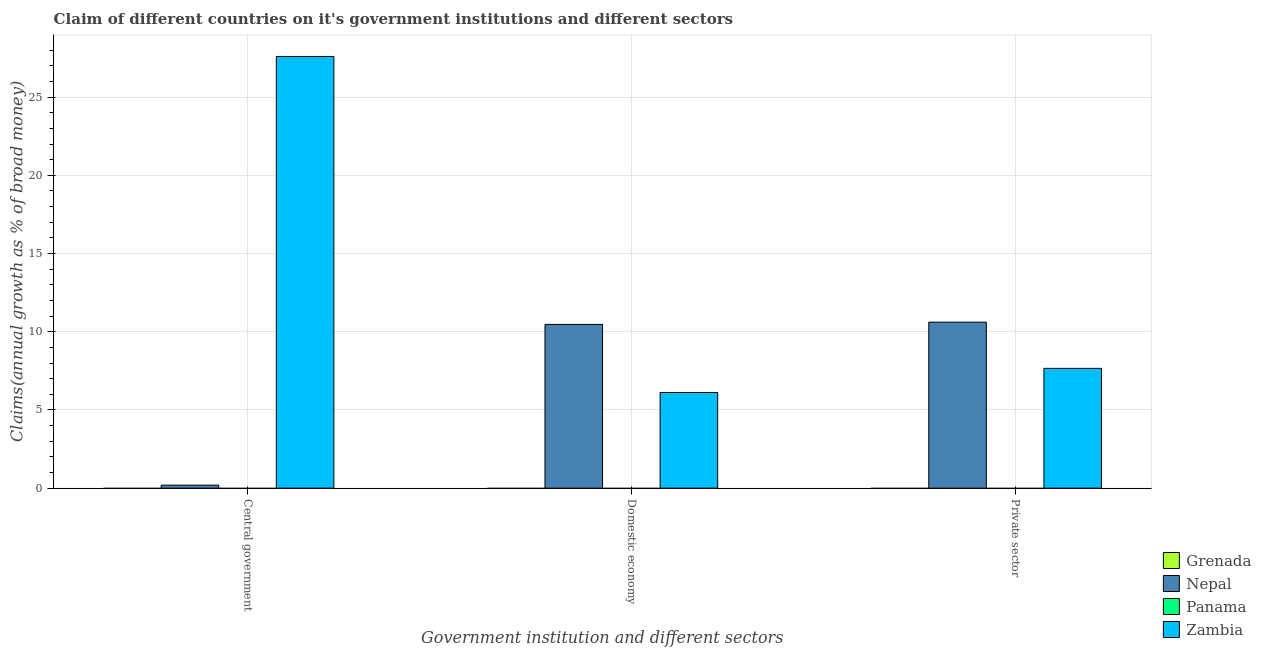How many different coloured bars are there?
Your response must be concise. 2. How many bars are there on the 3rd tick from the left?
Give a very brief answer. 2. How many bars are there on the 2nd tick from the right?
Give a very brief answer. 2. What is the label of the 2nd group of bars from the left?
Provide a succinct answer. Domestic economy. What is the percentage of claim on the domestic economy in Grenada?
Keep it short and to the point. 0. Across all countries, what is the maximum percentage of claim on the private sector?
Ensure brevity in your answer.  10.61. Across all countries, what is the minimum percentage of claim on the domestic economy?
Provide a short and direct response. 0. In which country was the percentage of claim on the central government maximum?
Offer a very short reply. Zambia. What is the total percentage of claim on the domestic economy in the graph?
Give a very brief answer. 16.59. What is the difference between the percentage of claim on the domestic economy in Zambia and that in Nepal?
Your response must be concise. -4.35. What is the difference between the percentage of claim on the central government in Panama and the percentage of claim on the private sector in Zambia?
Your response must be concise. -7.66. What is the average percentage of claim on the domestic economy per country?
Offer a very short reply. 4.15. What is the difference between the percentage of claim on the central government and percentage of claim on the domestic economy in Zambia?
Your answer should be very brief. 21.48. What is the ratio of the percentage of claim on the central government in Zambia to that in Nepal?
Offer a terse response. 142.06. Is the percentage of claim on the private sector in Nepal less than that in Zambia?
Provide a succinct answer. No. Is the difference between the percentage of claim on the central government in Zambia and Nepal greater than the difference between the percentage of claim on the private sector in Zambia and Nepal?
Make the answer very short. Yes. What is the difference between the highest and the lowest percentage of claim on the central government?
Provide a short and direct response. 27.6. What is the difference between two consecutive major ticks on the Y-axis?
Offer a terse response. 5. How many legend labels are there?
Your answer should be compact. 4. How are the legend labels stacked?
Keep it short and to the point. Vertical. What is the title of the graph?
Make the answer very short. Claim of different countries on it's government institutions and different sectors. What is the label or title of the X-axis?
Ensure brevity in your answer.  Government institution and different sectors. What is the label or title of the Y-axis?
Keep it short and to the point. Claims(annual growth as % of broad money). What is the Claims(annual growth as % of broad money) of Grenada in Central government?
Offer a terse response. 0. What is the Claims(annual growth as % of broad money) in Nepal in Central government?
Your answer should be very brief. 0.19. What is the Claims(annual growth as % of broad money) of Zambia in Central government?
Your answer should be very brief. 27.6. What is the Claims(annual growth as % of broad money) of Grenada in Domestic economy?
Ensure brevity in your answer.  0. What is the Claims(annual growth as % of broad money) of Nepal in Domestic economy?
Give a very brief answer. 10.47. What is the Claims(annual growth as % of broad money) of Zambia in Domestic economy?
Provide a short and direct response. 6.12. What is the Claims(annual growth as % of broad money) in Grenada in Private sector?
Provide a short and direct response. 0. What is the Claims(annual growth as % of broad money) in Nepal in Private sector?
Make the answer very short. 10.61. What is the Claims(annual growth as % of broad money) of Zambia in Private sector?
Offer a very short reply. 7.66. Across all Government institution and different sectors, what is the maximum Claims(annual growth as % of broad money) of Nepal?
Offer a very short reply. 10.61. Across all Government institution and different sectors, what is the maximum Claims(annual growth as % of broad money) of Zambia?
Give a very brief answer. 27.6. Across all Government institution and different sectors, what is the minimum Claims(annual growth as % of broad money) of Nepal?
Your answer should be very brief. 0.19. Across all Government institution and different sectors, what is the minimum Claims(annual growth as % of broad money) in Zambia?
Your response must be concise. 6.12. What is the total Claims(annual growth as % of broad money) of Grenada in the graph?
Give a very brief answer. 0. What is the total Claims(annual growth as % of broad money) of Nepal in the graph?
Your answer should be very brief. 21.28. What is the total Claims(annual growth as % of broad money) in Zambia in the graph?
Provide a short and direct response. 41.38. What is the difference between the Claims(annual growth as % of broad money) of Nepal in Central government and that in Domestic economy?
Offer a terse response. -10.28. What is the difference between the Claims(annual growth as % of broad money) of Zambia in Central government and that in Domestic economy?
Provide a short and direct response. 21.48. What is the difference between the Claims(annual growth as % of broad money) in Nepal in Central government and that in Private sector?
Your answer should be very brief. -10.42. What is the difference between the Claims(annual growth as % of broad money) in Zambia in Central government and that in Private sector?
Make the answer very short. 19.94. What is the difference between the Claims(annual growth as % of broad money) of Nepal in Domestic economy and that in Private sector?
Provide a succinct answer. -0.14. What is the difference between the Claims(annual growth as % of broad money) of Zambia in Domestic economy and that in Private sector?
Provide a short and direct response. -1.54. What is the difference between the Claims(annual growth as % of broad money) of Nepal in Central government and the Claims(annual growth as % of broad money) of Zambia in Domestic economy?
Offer a terse response. -5.92. What is the difference between the Claims(annual growth as % of broad money) in Nepal in Central government and the Claims(annual growth as % of broad money) in Zambia in Private sector?
Your answer should be compact. -7.46. What is the difference between the Claims(annual growth as % of broad money) in Nepal in Domestic economy and the Claims(annual growth as % of broad money) in Zambia in Private sector?
Your answer should be very brief. 2.81. What is the average Claims(annual growth as % of broad money) of Grenada per Government institution and different sectors?
Your answer should be very brief. 0. What is the average Claims(annual growth as % of broad money) in Nepal per Government institution and different sectors?
Provide a succinct answer. 7.09. What is the average Claims(annual growth as % of broad money) of Zambia per Government institution and different sectors?
Provide a short and direct response. 13.79. What is the difference between the Claims(annual growth as % of broad money) of Nepal and Claims(annual growth as % of broad money) of Zambia in Central government?
Offer a terse response. -27.41. What is the difference between the Claims(annual growth as % of broad money) in Nepal and Claims(annual growth as % of broad money) in Zambia in Domestic economy?
Keep it short and to the point. 4.35. What is the difference between the Claims(annual growth as % of broad money) of Nepal and Claims(annual growth as % of broad money) of Zambia in Private sector?
Offer a terse response. 2.95. What is the ratio of the Claims(annual growth as % of broad money) in Nepal in Central government to that in Domestic economy?
Your response must be concise. 0.02. What is the ratio of the Claims(annual growth as % of broad money) in Zambia in Central government to that in Domestic economy?
Keep it short and to the point. 4.51. What is the ratio of the Claims(annual growth as % of broad money) in Nepal in Central government to that in Private sector?
Offer a terse response. 0.02. What is the ratio of the Claims(annual growth as % of broad money) in Zambia in Central government to that in Private sector?
Give a very brief answer. 3.6. What is the ratio of the Claims(annual growth as % of broad money) of Nepal in Domestic economy to that in Private sector?
Offer a very short reply. 0.99. What is the ratio of the Claims(annual growth as % of broad money) of Zambia in Domestic economy to that in Private sector?
Your response must be concise. 0.8. What is the difference between the highest and the second highest Claims(annual growth as % of broad money) of Nepal?
Give a very brief answer. 0.14. What is the difference between the highest and the second highest Claims(annual growth as % of broad money) of Zambia?
Offer a terse response. 19.94. What is the difference between the highest and the lowest Claims(annual growth as % of broad money) of Nepal?
Provide a succinct answer. 10.42. What is the difference between the highest and the lowest Claims(annual growth as % of broad money) in Zambia?
Keep it short and to the point. 21.48. 